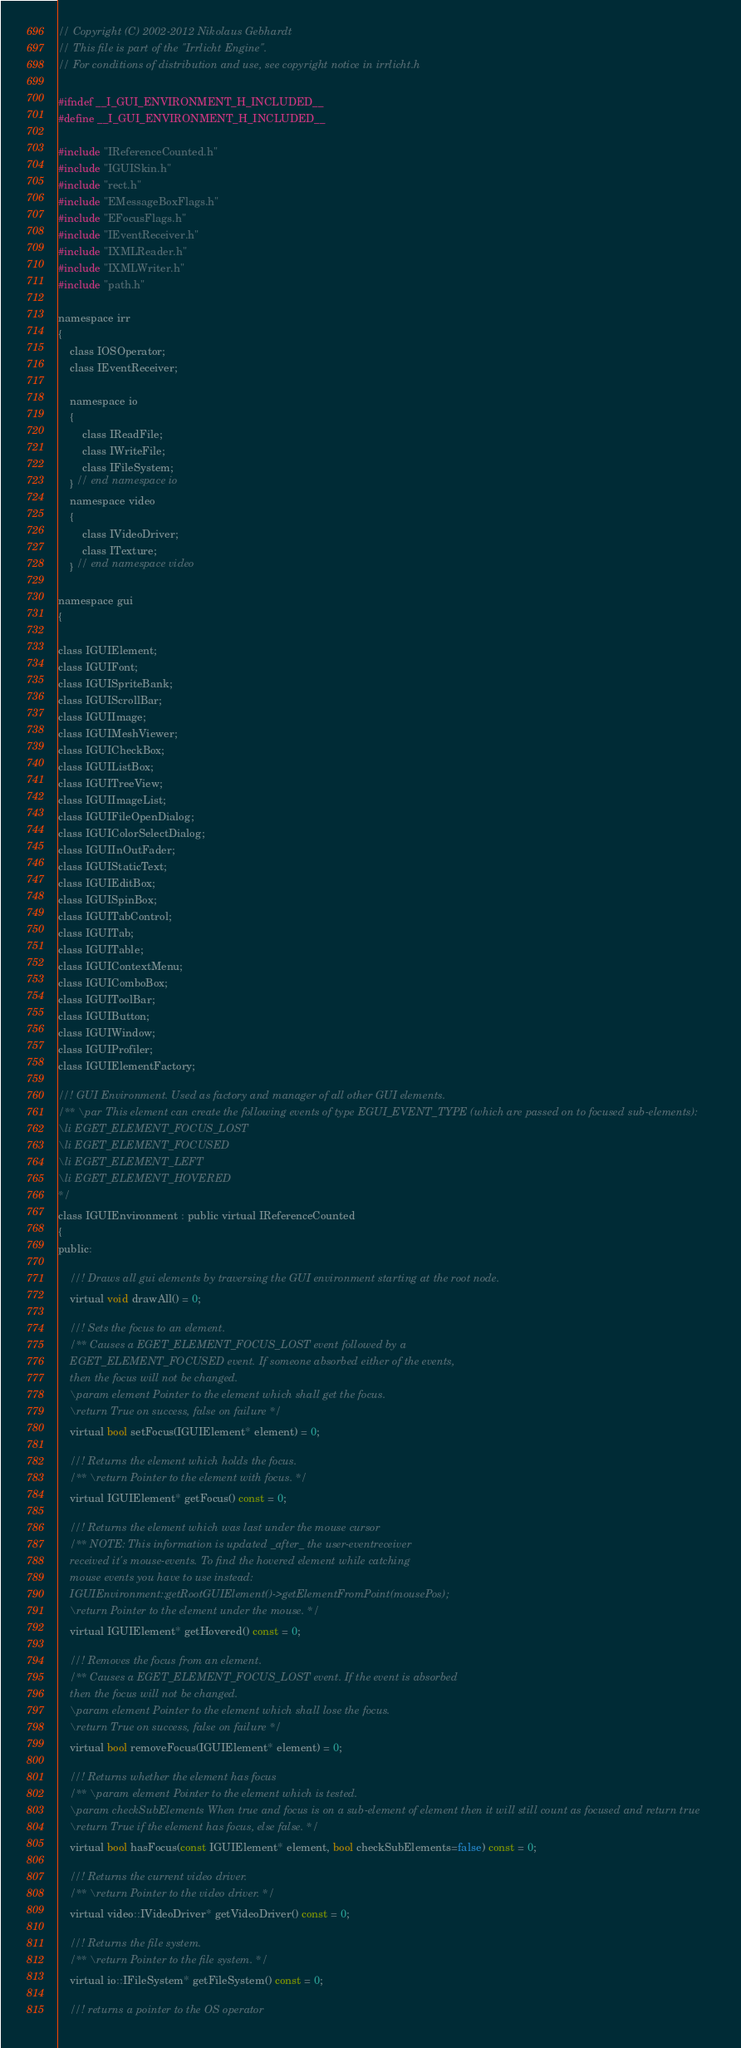<code> <loc_0><loc_0><loc_500><loc_500><_C_>// Copyright (C) 2002-2012 Nikolaus Gebhardt
// This file is part of the "Irrlicht Engine".
// For conditions of distribution and use, see copyright notice in irrlicht.h

#ifndef __I_GUI_ENVIRONMENT_H_INCLUDED__
#define __I_GUI_ENVIRONMENT_H_INCLUDED__

#include "IReferenceCounted.h"
#include "IGUISkin.h"
#include "rect.h"
#include "EMessageBoxFlags.h"
#include "EFocusFlags.h"
#include "IEventReceiver.h"
#include "IXMLReader.h"
#include "IXMLWriter.h"
#include "path.h"

namespace irr
{
	class IOSOperator;
	class IEventReceiver;

	namespace io
	{
		class IReadFile;
		class IWriteFile;
		class IFileSystem;
	} // end namespace io
	namespace video
	{
		class IVideoDriver;
		class ITexture;
	} // end namespace video

namespace gui
{

class IGUIElement;
class IGUIFont;
class IGUISpriteBank;
class IGUIScrollBar;
class IGUIImage;
class IGUIMeshViewer;
class IGUICheckBox;
class IGUIListBox;
class IGUITreeView;
class IGUIImageList;
class IGUIFileOpenDialog;
class IGUIColorSelectDialog;
class IGUIInOutFader;
class IGUIStaticText;
class IGUIEditBox;
class IGUISpinBox;
class IGUITabControl;
class IGUITab;
class IGUITable;
class IGUIContextMenu;
class IGUIComboBox;
class IGUIToolBar;
class IGUIButton;
class IGUIWindow;
class IGUIProfiler;
class IGUIElementFactory;

//! GUI Environment. Used as factory and manager of all other GUI elements.
/** \par This element can create the following events of type EGUI_EVENT_TYPE (which are passed on to focused sub-elements):
\li EGET_ELEMENT_FOCUS_LOST
\li EGET_ELEMENT_FOCUSED
\li EGET_ELEMENT_LEFT
\li EGET_ELEMENT_HOVERED
*/
class IGUIEnvironment : public virtual IReferenceCounted
{
public:

	//! Draws all gui elements by traversing the GUI environment starting at the root node.
	virtual void drawAll() = 0;

	//! Sets the focus to an element.
	/** Causes a EGET_ELEMENT_FOCUS_LOST event followed by a
	EGET_ELEMENT_FOCUSED event. If someone absorbed either of the events,
	then the focus will not be changed.
	\param element Pointer to the element which shall get the focus.
	\return True on success, false on failure */
	virtual bool setFocus(IGUIElement* element) = 0;

	//! Returns the element which holds the focus.
	/** \return Pointer to the element with focus. */
	virtual IGUIElement* getFocus() const = 0;

	//! Returns the element which was last under the mouse cursor
	/** NOTE: This information is updated _after_ the user-eventreceiver
	received it's mouse-events. To find the hovered element while catching
	mouse events you have to use instead:
	IGUIEnvironment::getRootGUIElement()->getElementFromPoint(mousePos);
	\return Pointer to the element under the mouse. */
	virtual IGUIElement* getHovered() const = 0;

	//! Removes the focus from an element.
	/** Causes a EGET_ELEMENT_FOCUS_LOST event. If the event is absorbed
	then the focus will not be changed.
	\param element Pointer to the element which shall lose the focus.
	\return True on success, false on failure */
	virtual bool removeFocus(IGUIElement* element) = 0;

	//! Returns whether the element has focus
	/** \param element Pointer to the element which is tested.
	\param checkSubElements When true and focus is on a sub-element of element then it will still count as focused and return true
	\return True if the element has focus, else false. */
	virtual bool hasFocus(const IGUIElement* element, bool checkSubElements=false) const = 0;

	//! Returns the current video driver.
	/** \return Pointer to the video driver. */
	virtual video::IVideoDriver* getVideoDriver() const = 0;

	//! Returns the file system.
	/** \return Pointer to the file system. */
	virtual io::IFileSystem* getFileSystem() const = 0;

	//! returns a pointer to the OS operator</code> 